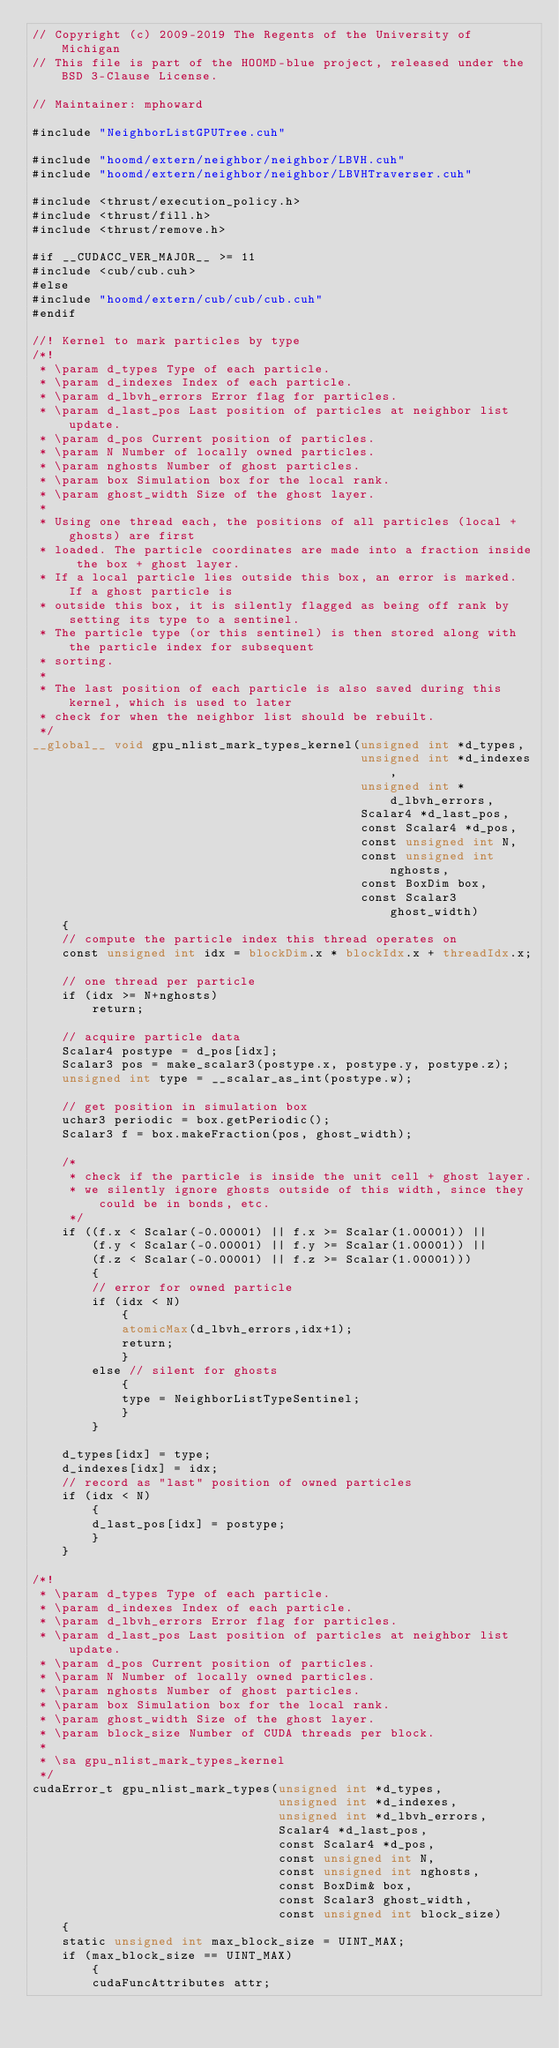<code> <loc_0><loc_0><loc_500><loc_500><_Cuda_>// Copyright (c) 2009-2019 The Regents of the University of Michigan
// This file is part of the HOOMD-blue project, released under the BSD 3-Clause License.

// Maintainer: mphoward

#include "NeighborListGPUTree.cuh"

#include "hoomd/extern/neighbor/neighbor/LBVH.cuh"
#include "hoomd/extern/neighbor/neighbor/LBVHTraverser.cuh"

#include <thrust/execution_policy.h>
#include <thrust/fill.h>
#include <thrust/remove.h>

#if __CUDACC_VER_MAJOR__ >= 11
#include <cub/cub.cuh>
#else
#include "hoomd/extern/cub/cub/cub.cuh"
#endif

//! Kernel to mark particles by type
/*!
 * \param d_types Type of each particle.
 * \param d_indexes Index of each particle.
 * \param d_lbvh_errors Error flag for particles.
 * \param d_last_pos Last position of particles at neighbor list update.
 * \param d_pos Current position of particles.
 * \param N Number of locally owned particles.
 * \param nghosts Number of ghost particles.
 * \param box Simulation box for the local rank.
 * \param ghost_width Size of the ghost layer.
 *
 * Using one thread each, the positions of all particles (local + ghosts) are first
 * loaded. The particle coordinates are made into a fraction inside the box + ghost layer.
 * If a local particle lies outside this box, an error is marked. If a ghost particle is
 * outside this box, it is silently flagged as being off rank by setting its type to a sentinel.
 * The particle type (or this sentinel) is then stored along with the particle index for subsequent
 * sorting.
 *
 * The last position of each particle is also saved during this kernel, which is used to later
 * check for when the neighbor list should be rebuilt.
 */
__global__ void gpu_nlist_mark_types_kernel(unsigned int *d_types,
                                            unsigned int *d_indexes,
                                            unsigned int *d_lbvh_errors,
                                            Scalar4 *d_last_pos,
                                            const Scalar4 *d_pos,
                                            const unsigned int N,
                                            const unsigned int nghosts,
                                            const BoxDim box,
                                            const Scalar3 ghost_width)
    {
    // compute the particle index this thread operates on
    const unsigned int idx = blockDim.x * blockIdx.x + threadIdx.x;

    // one thread per particle
    if (idx >= N+nghosts)
        return;

    // acquire particle data
    Scalar4 postype = d_pos[idx];
    Scalar3 pos = make_scalar3(postype.x, postype.y, postype.z);
    unsigned int type = __scalar_as_int(postype.w);

    // get position in simulation box
    uchar3 periodic = box.getPeriodic();
    Scalar3 f = box.makeFraction(pos, ghost_width);

    /*
     * check if the particle is inside the unit cell + ghost layer.
     * we silently ignore ghosts outside of this width, since they could be in bonds, etc.
     */
    if ((f.x < Scalar(-0.00001) || f.x >= Scalar(1.00001)) ||
        (f.y < Scalar(-0.00001) || f.y >= Scalar(1.00001)) ||
        (f.z < Scalar(-0.00001) || f.z >= Scalar(1.00001)))
        {
        // error for owned particle
        if (idx < N)
            {
            atomicMax(d_lbvh_errors,idx+1);
            return;
            }
        else // silent for ghosts
            {
            type = NeighborListTypeSentinel;
            }
        }

    d_types[idx] = type;
    d_indexes[idx] = idx;
    // record as "last" position of owned particles
    if (idx < N)
        {
        d_last_pos[idx] = postype;
        }
    }

/*!
 * \param d_types Type of each particle.
 * \param d_indexes Index of each particle.
 * \param d_lbvh_errors Error flag for particles.
 * \param d_last_pos Last position of particles at neighbor list update.
 * \param d_pos Current position of particles.
 * \param N Number of locally owned particles.
 * \param nghosts Number of ghost particles.
 * \param box Simulation box for the local rank.
 * \param ghost_width Size of the ghost layer.
 * \param block_size Number of CUDA threads per block.
 *
 * \sa gpu_nlist_mark_types_kernel
 */
cudaError_t gpu_nlist_mark_types(unsigned int *d_types,
                                 unsigned int *d_indexes,
                                 unsigned int *d_lbvh_errors,
                                 Scalar4 *d_last_pos,
                                 const Scalar4 *d_pos,
                                 const unsigned int N,
                                 const unsigned int nghosts,
                                 const BoxDim& box,
                                 const Scalar3 ghost_width,
                                 const unsigned int block_size)
    {
    static unsigned int max_block_size = UINT_MAX;
    if (max_block_size == UINT_MAX)
        {
        cudaFuncAttributes attr;</code> 